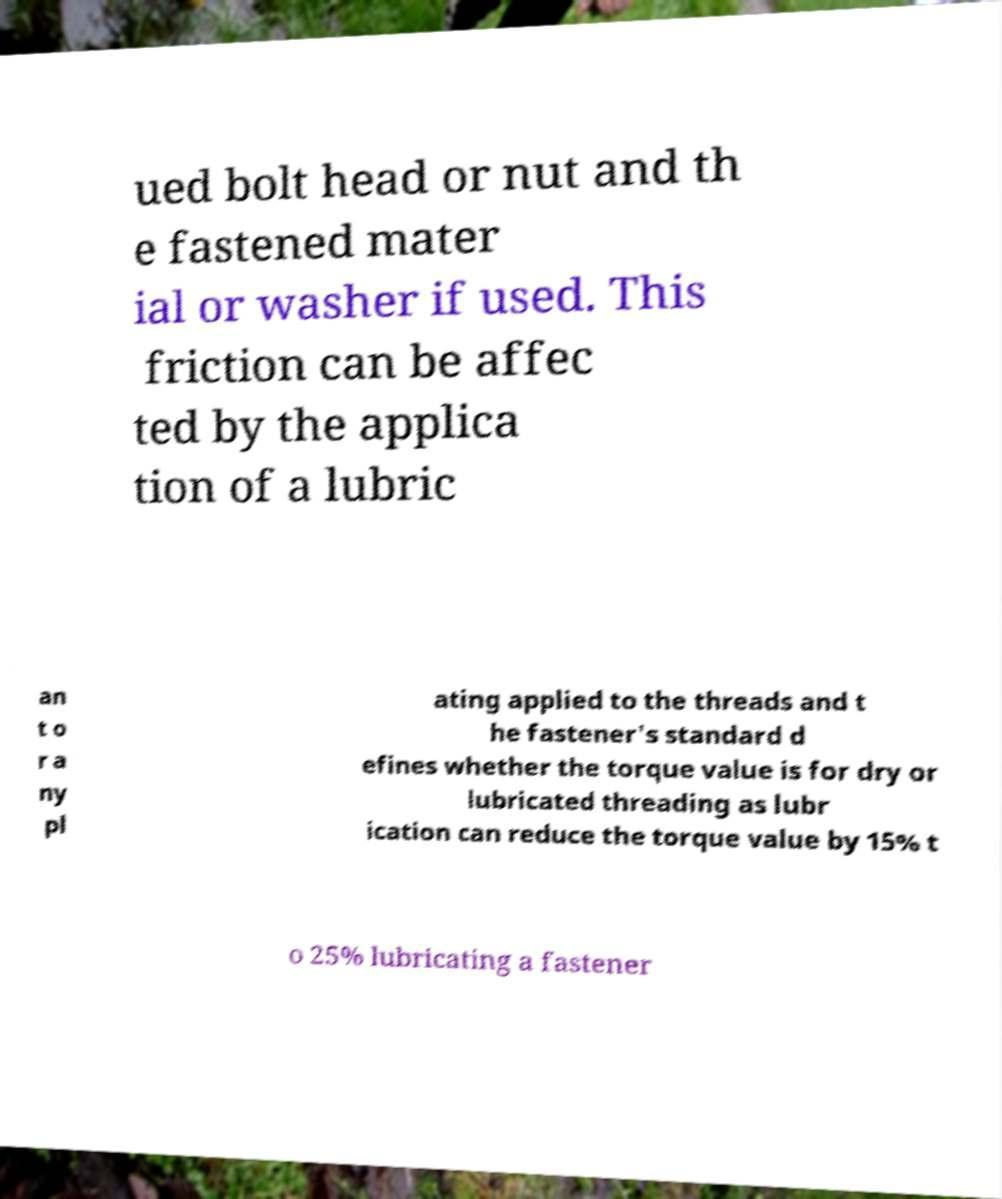Could you assist in decoding the text presented in this image and type it out clearly? ued bolt head or nut and th e fastened mater ial or washer if used. This friction can be affec ted by the applica tion of a lubric an t o r a ny pl ating applied to the threads and t he fastener's standard d efines whether the torque value is for dry or lubricated threading as lubr ication can reduce the torque value by 15% t o 25% lubricating a fastener 